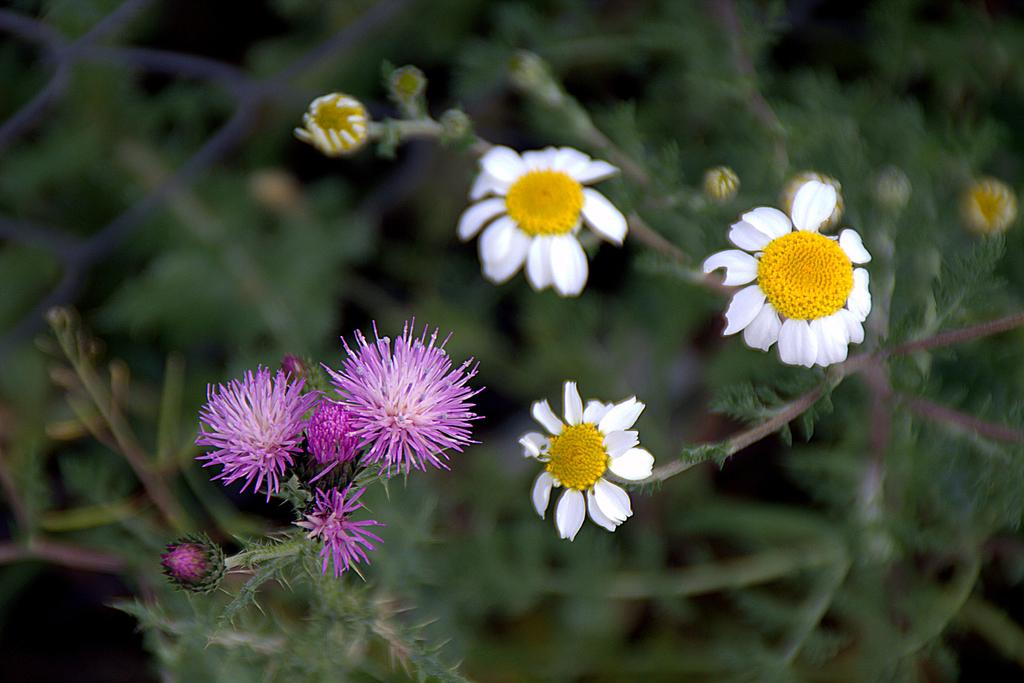What type of plants can be seen in the image? There are plants with flowers in the image. Can you describe the background of the image? The background of the image is blurred. What type of butter is being sold in the shop in the image? There is no shop or butter present in the image; it features plants with flowers and a blurred background. 